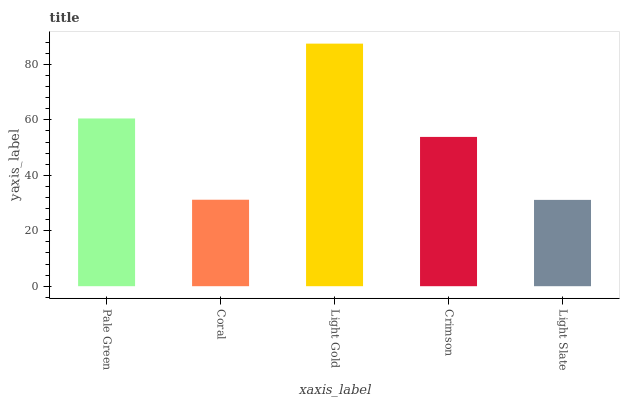Is Light Slate the minimum?
Answer yes or no. Yes. Is Light Gold the maximum?
Answer yes or no. Yes. Is Coral the minimum?
Answer yes or no. No. Is Coral the maximum?
Answer yes or no. No. Is Pale Green greater than Coral?
Answer yes or no. Yes. Is Coral less than Pale Green?
Answer yes or no. Yes. Is Coral greater than Pale Green?
Answer yes or no. No. Is Pale Green less than Coral?
Answer yes or no. No. Is Crimson the high median?
Answer yes or no. Yes. Is Crimson the low median?
Answer yes or no. Yes. Is Coral the high median?
Answer yes or no. No. Is Pale Green the low median?
Answer yes or no. No. 